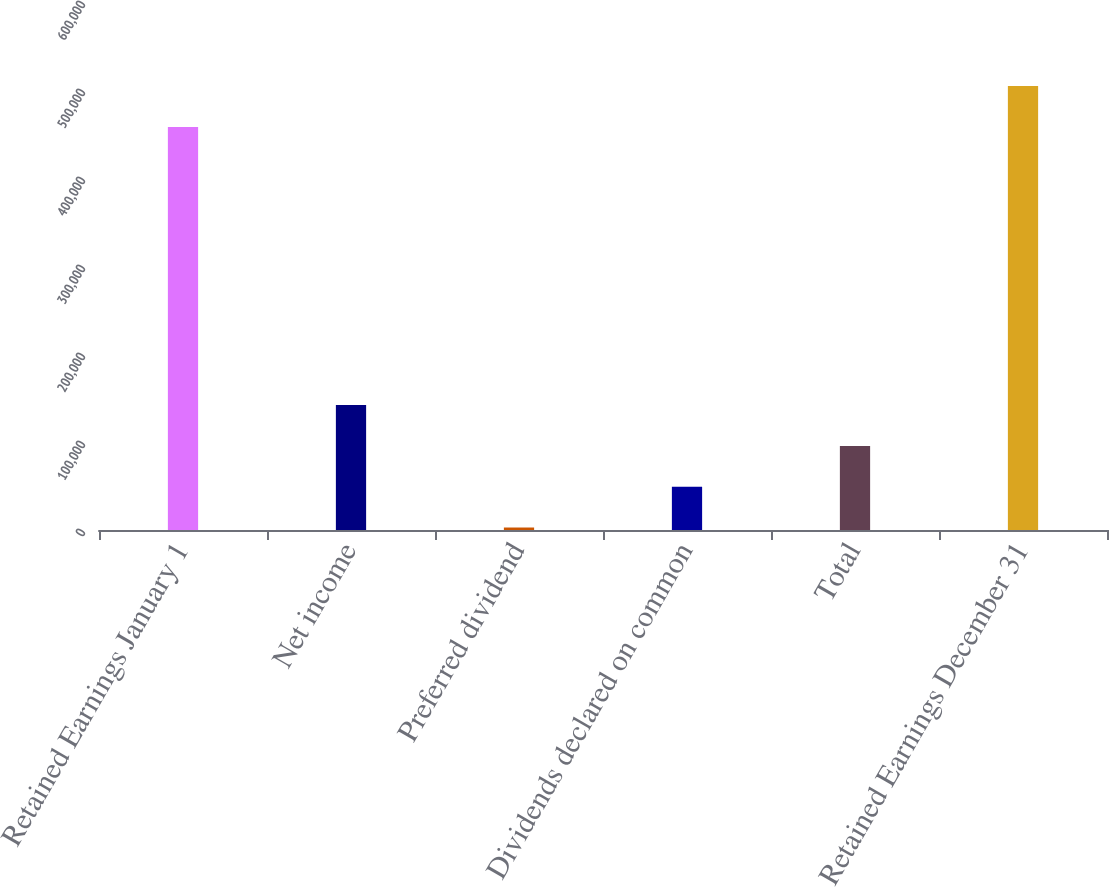<chart> <loc_0><loc_0><loc_500><loc_500><bar_chart><fcel>Retained Earnings January 1<fcel>Net income<fcel>Preferred dividend<fcel>Dividends declared on common<fcel>Total<fcel>Retained Earnings December 31<nl><fcel>458039<fcel>141966<fcel>2828<fcel>49207.3<fcel>95586.6<fcel>504418<nl></chart> 